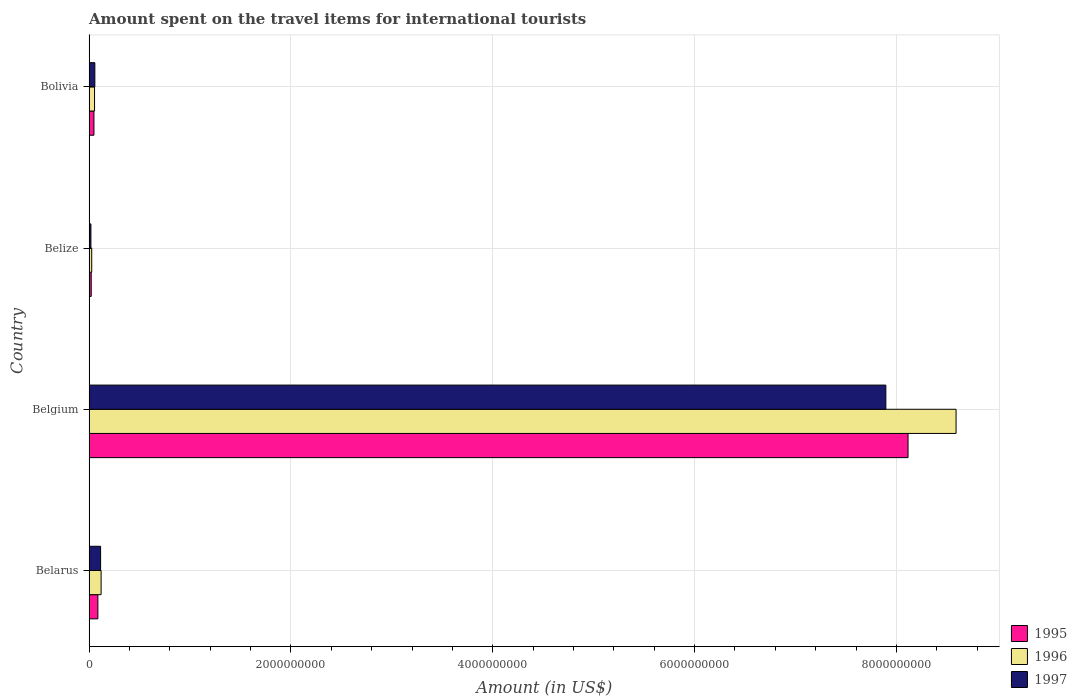How many groups of bars are there?
Provide a succinct answer. 4. Are the number of bars per tick equal to the number of legend labels?
Offer a terse response. Yes. How many bars are there on the 3rd tick from the top?
Your answer should be very brief. 3. What is the label of the 2nd group of bars from the top?
Provide a succinct answer. Belize. In how many cases, is the number of bars for a given country not equal to the number of legend labels?
Your answer should be compact. 0. What is the amount spent on the travel items for international tourists in 1995 in Belarus?
Provide a short and direct response. 8.70e+07. Across all countries, what is the maximum amount spent on the travel items for international tourists in 1995?
Provide a short and direct response. 8.12e+09. Across all countries, what is the minimum amount spent on the travel items for international tourists in 1995?
Ensure brevity in your answer.  2.10e+07. In which country was the amount spent on the travel items for international tourists in 1997 minimum?
Offer a very short reply. Belize. What is the total amount spent on the travel items for international tourists in 1997 in the graph?
Offer a very short reply. 8.08e+09. What is the difference between the amount spent on the travel items for international tourists in 1996 in Belize and that in Bolivia?
Ensure brevity in your answer.  -2.80e+07. What is the difference between the amount spent on the travel items for international tourists in 1996 in Bolivia and the amount spent on the travel items for international tourists in 1995 in Belarus?
Give a very brief answer. -3.30e+07. What is the average amount spent on the travel items for international tourists in 1996 per country?
Provide a succinct answer. 2.20e+09. What is the difference between the amount spent on the travel items for international tourists in 1995 and amount spent on the travel items for international tourists in 1997 in Bolivia?
Provide a short and direct response. -9.00e+06. In how many countries, is the amount spent on the travel items for international tourists in 1997 greater than 8000000000 US$?
Offer a terse response. 0. What is the ratio of the amount spent on the travel items for international tourists in 1997 in Belgium to that in Belize?
Offer a very short reply. 438.61. What is the difference between the highest and the second highest amount spent on the travel items for international tourists in 1997?
Offer a very short reply. 7.78e+09. What is the difference between the highest and the lowest amount spent on the travel items for international tourists in 1997?
Ensure brevity in your answer.  7.88e+09. What does the 2nd bar from the top in Belize represents?
Make the answer very short. 1996. What does the 2nd bar from the bottom in Belarus represents?
Make the answer very short. 1996. Is it the case that in every country, the sum of the amount spent on the travel items for international tourists in 1997 and amount spent on the travel items for international tourists in 1996 is greater than the amount spent on the travel items for international tourists in 1995?
Offer a very short reply. Yes. Are all the bars in the graph horizontal?
Make the answer very short. Yes. How many countries are there in the graph?
Your response must be concise. 4. Are the values on the major ticks of X-axis written in scientific E-notation?
Provide a short and direct response. No. Does the graph contain any zero values?
Make the answer very short. No. Does the graph contain grids?
Provide a succinct answer. Yes. How many legend labels are there?
Give a very brief answer. 3. How are the legend labels stacked?
Keep it short and to the point. Vertical. What is the title of the graph?
Offer a very short reply. Amount spent on the travel items for international tourists. Does "2012" appear as one of the legend labels in the graph?
Make the answer very short. No. What is the label or title of the X-axis?
Keep it short and to the point. Amount (in US$). What is the Amount (in US$) of 1995 in Belarus?
Give a very brief answer. 8.70e+07. What is the Amount (in US$) of 1996 in Belarus?
Offer a terse response. 1.19e+08. What is the Amount (in US$) in 1997 in Belarus?
Keep it short and to the point. 1.14e+08. What is the Amount (in US$) in 1995 in Belgium?
Provide a succinct answer. 8.12e+09. What is the Amount (in US$) in 1996 in Belgium?
Offer a very short reply. 8.59e+09. What is the Amount (in US$) of 1997 in Belgium?
Offer a very short reply. 7.90e+09. What is the Amount (in US$) in 1995 in Belize?
Your response must be concise. 2.10e+07. What is the Amount (in US$) of 1996 in Belize?
Offer a very short reply. 2.60e+07. What is the Amount (in US$) of 1997 in Belize?
Offer a terse response. 1.80e+07. What is the Amount (in US$) in 1995 in Bolivia?
Offer a very short reply. 4.80e+07. What is the Amount (in US$) in 1996 in Bolivia?
Provide a short and direct response. 5.40e+07. What is the Amount (in US$) in 1997 in Bolivia?
Offer a very short reply. 5.70e+07. Across all countries, what is the maximum Amount (in US$) in 1995?
Ensure brevity in your answer.  8.12e+09. Across all countries, what is the maximum Amount (in US$) in 1996?
Your answer should be compact. 8.59e+09. Across all countries, what is the maximum Amount (in US$) in 1997?
Provide a succinct answer. 7.90e+09. Across all countries, what is the minimum Amount (in US$) in 1995?
Your response must be concise. 2.10e+07. Across all countries, what is the minimum Amount (in US$) in 1996?
Your response must be concise. 2.60e+07. Across all countries, what is the minimum Amount (in US$) of 1997?
Provide a short and direct response. 1.80e+07. What is the total Amount (in US$) of 1995 in the graph?
Your answer should be very brief. 8.27e+09. What is the total Amount (in US$) in 1996 in the graph?
Offer a very short reply. 8.79e+09. What is the total Amount (in US$) of 1997 in the graph?
Offer a terse response. 8.08e+09. What is the difference between the Amount (in US$) in 1995 in Belarus and that in Belgium?
Your answer should be compact. -8.03e+09. What is the difference between the Amount (in US$) of 1996 in Belarus and that in Belgium?
Ensure brevity in your answer.  -8.47e+09. What is the difference between the Amount (in US$) in 1997 in Belarus and that in Belgium?
Your answer should be compact. -7.78e+09. What is the difference between the Amount (in US$) of 1995 in Belarus and that in Belize?
Offer a very short reply. 6.60e+07. What is the difference between the Amount (in US$) of 1996 in Belarus and that in Belize?
Your response must be concise. 9.30e+07. What is the difference between the Amount (in US$) in 1997 in Belarus and that in Belize?
Give a very brief answer. 9.60e+07. What is the difference between the Amount (in US$) in 1995 in Belarus and that in Bolivia?
Provide a short and direct response. 3.90e+07. What is the difference between the Amount (in US$) of 1996 in Belarus and that in Bolivia?
Your answer should be very brief. 6.50e+07. What is the difference between the Amount (in US$) of 1997 in Belarus and that in Bolivia?
Your answer should be very brief. 5.70e+07. What is the difference between the Amount (in US$) of 1995 in Belgium and that in Belize?
Provide a short and direct response. 8.09e+09. What is the difference between the Amount (in US$) of 1996 in Belgium and that in Belize?
Make the answer very short. 8.56e+09. What is the difference between the Amount (in US$) of 1997 in Belgium and that in Belize?
Your answer should be very brief. 7.88e+09. What is the difference between the Amount (in US$) of 1995 in Belgium and that in Bolivia?
Your answer should be compact. 8.07e+09. What is the difference between the Amount (in US$) in 1996 in Belgium and that in Bolivia?
Keep it short and to the point. 8.54e+09. What is the difference between the Amount (in US$) of 1997 in Belgium and that in Bolivia?
Ensure brevity in your answer.  7.84e+09. What is the difference between the Amount (in US$) of 1995 in Belize and that in Bolivia?
Your answer should be compact. -2.70e+07. What is the difference between the Amount (in US$) in 1996 in Belize and that in Bolivia?
Ensure brevity in your answer.  -2.80e+07. What is the difference between the Amount (in US$) of 1997 in Belize and that in Bolivia?
Ensure brevity in your answer.  -3.90e+07. What is the difference between the Amount (in US$) of 1995 in Belarus and the Amount (in US$) of 1996 in Belgium?
Your answer should be very brief. -8.50e+09. What is the difference between the Amount (in US$) of 1995 in Belarus and the Amount (in US$) of 1997 in Belgium?
Make the answer very short. -7.81e+09. What is the difference between the Amount (in US$) in 1996 in Belarus and the Amount (in US$) in 1997 in Belgium?
Offer a terse response. -7.78e+09. What is the difference between the Amount (in US$) in 1995 in Belarus and the Amount (in US$) in 1996 in Belize?
Offer a terse response. 6.10e+07. What is the difference between the Amount (in US$) of 1995 in Belarus and the Amount (in US$) of 1997 in Belize?
Give a very brief answer. 6.90e+07. What is the difference between the Amount (in US$) in 1996 in Belarus and the Amount (in US$) in 1997 in Belize?
Your answer should be very brief. 1.01e+08. What is the difference between the Amount (in US$) of 1995 in Belarus and the Amount (in US$) of 1996 in Bolivia?
Make the answer very short. 3.30e+07. What is the difference between the Amount (in US$) of 1995 in Belarus and the Amount (in US$) of 1997 in Bolivia?
Your answer should be compact. 3.00e+07. What is the difference between the Amount (in US$) of 1996 in Belarus and the Amount (in US$) of 1997 in Bolivia?
Your response must be concise. 6.20e+07. What is the difference between the Amount (in US$) of 1995 in Belgium and the Amount (in US$) of 1996 in Belize?
Your answer should be compact. 8.09e+09. What is the difference between the Amount (in US$) of 1995 in Belgium and the Amount (in US$) of 1997 in Belize?
Your answer should be very brief. 8.10e+09. What is the difference between the Amount (in US$) in 1996 in Belgium and the Amount (in US$) in 1997 in Belize?
Keep it short and to the point. 8.57e+09. What is the difference between the Amount (in US$) in 1995 in Belgium and the Amount (in US$) in 1996 in Bolivia?
Ensure brevity in your answer.  8.06e+09. What is the difference between the Amount (in US$) of 1995 in Belgium and the Amount (in US$) of 1997 in Bolivia?
Your response must be concise. 8.06e+09. What is the difference between the Amount (in US$) of 1996 in Belgium and the Amount (in US$) of 1997 in Bolivia?
Offer a very short reply. 8.53e+09. What is the difference between the Amount (in US$) in 1995 in Belize and the Amount (in US$) in 1996 in Bolivia?
Offer a very short reply. -3.30e+07. What is the difference between the Amount (in US$) in 1995 in Belize and the Amount (in US$) in 1997 in Bolivia?
Ensure brevity in your answer.  -3.60e+07. What is the difference between the Amount (in US$) in 1996 in Belize and the Amount (in US$) in 1997 in Bolivia?
Give a very brief answer. -3.10e+07. What is the average Amount (in US$) of 1995 per country?
Offer a terse response. 2.07e+09. What is the average Amount (in US$) of 1996 per country?
Provide a short and direct response. 2.20e+09. What is the average Amount (in US$) in 1997 per country?
Your answer should be very brief. 2.02e+09. What is the difference between the Amount (in US$) in 1995 and Amount (in US$) in 1996 in Belarus?
Your answer should be very brief. -3.20e+07. What is the difference between the Amount (in US$) of 1995 and Amount (in US$) of 1997 in Belarus?
Ensure brevity in your answer.  -2.70e+07. What is the difference between the Amount (in US$) of 1995 and Amount (in US$) of 1996 in Belgium?
Your answer should be compact. -4.76e+08. What is the difference between the Amount (in US$) of 1995 and Amount (in US$) of 1997 in Belgium?
Your response must be concise. 2.20e+08. What is the difference between the Amount (in US$) of 1996 and Amount (in US$) of 1997 in Belgium?
Your answer should be compact. 6.96e+08. What is the difference between the Amount (in US$) of 1995 and Amount (in US$) of 1996 in Belize?
Ensure brevity in your answer.  -5.00e+06. What is the difference between the Amount (in US$) of 1995 and Amount (in US$) of 1996 in Bolivia?
Your response must be concise. -6.00e+06. What is the difference between the Amount (in US$) in 1995 and Amount (in US$) in 1997 in Bolivia?
Ensure brevity in your answer.  -9.00e+06. What is the ratio of the Amount (in US$) of 1995 in Belarus to that in Belgium?
Keep it short and to the point. 0.01. What is the ratio of the Amount (in US$) in 1996 in Belarus to that in Belgium?
Provide a succinct answer. 0.01. What is the ratio of the Amount (in US$) in 1997 in Belarus to that in Belgium?
Your answer should be very brief. 0.01. What is the ratio of the Amount (in US$) of 1995 in Belarus to that in Belize?
Offer a very short reply. 4.14. What is the ratio of the Amount (in US$) in 1996 in Belarus to that in Belize?
Provide a short and direct response. 4.58. What is the ratio of the Amount (in US$) of 1997 in Belarus to that in Belize?
Your response must be concise. 6.33. What is the ratio of the Amount (in US$) in 1995 in Belarus to that in Bolivia?
Offer a very short reply. 1.81. What is the ratio of the Amount (in US$) of 1996 in Belarus to that in Bolivia?
Make the answer very short. 2.2. What is the ratio of the Amount (in US$) in 1997 in Belarus to that in Bolivia?
Give a very brief answer. 2. What is the ratio of the Amount (in US$) of 1995 in Belgium to that in Belize?
Your answer should be compact. 386.43. What is the ratio of the Amount (in US$) in 1996 in Belgium to that in Belize?
Make the answer very short. 330.42. What is the ratio of the Amount (in US$) in 1997 in Belgium to that in Belize?
Provide a short and direct response. 438.61. What is the ratio of the Amount (in US$) of 1995 in Belgium to that in Bolivia?
Offer a very short reply. 169.06. What is the ratio of the Amount (in US$) in 1996 in Belgium to that in Bolivia?
Offer a very short reply. 159.09. What is the ratio of the Amount (in US$) of 1997 in Belgium to that in Bolivia?
Your response must be concise. 138.51. What is the ratio of the Amount (in US$) in 1995 in Belize to that in Bolivia?
Ensure brevity in your answer.  0.44. What is the ratio of the Amount (in US$) of 1996 in Belize to that in Bolivia?
Offer a terse response. 0.48. What is the ratio of the Amount (in US$) in 1997 in Belize to that in Bolivia?
Ensure brevity in your answer.  0.32. What is the difference between the highest and the second highest Amount (in US$) of 1995?
Make the answer very short. 8.03e+09. What is the difference between the highest and the second highest Amount (in US$) in 1996?
Ensure brevity in your answer.  8.47e+09. What is the difference between the highest and the second highest Amount (in US$) in 1997?
Give a very brief answer. 7.78e+09. What is the difference between the highest and the lowest Amount (in US$) of 1995?
Your answer should be compact. 8.09e+09. What is the difference between the highest and the lowest Amount (in US$) in 1996?
Keep it short and to the point. 8.56e+09. What is the difference between the highest and the lowest Amount (in US$) of 1997?
Your response must be concise. 7.88e+09. 